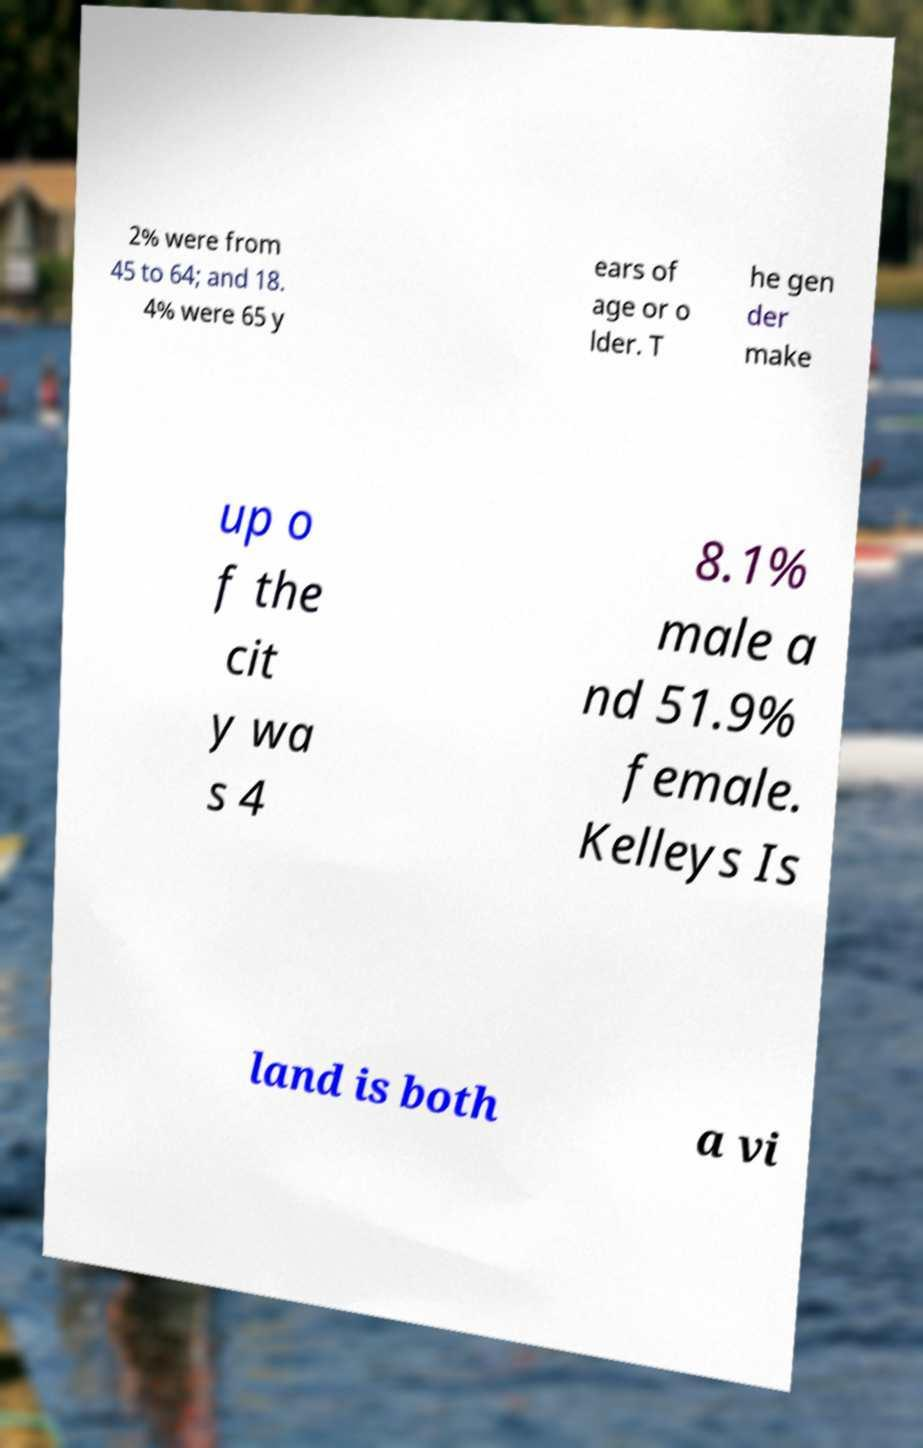Could you extract and type out the text from this image? 2% were from 45 to 64; and 18. 4% were 65 y ears of age or o lder. T he gen der make up o f the cit y wa s 4 8.1% male a nd 51.9% female. Kelleys Is land is both a vi 